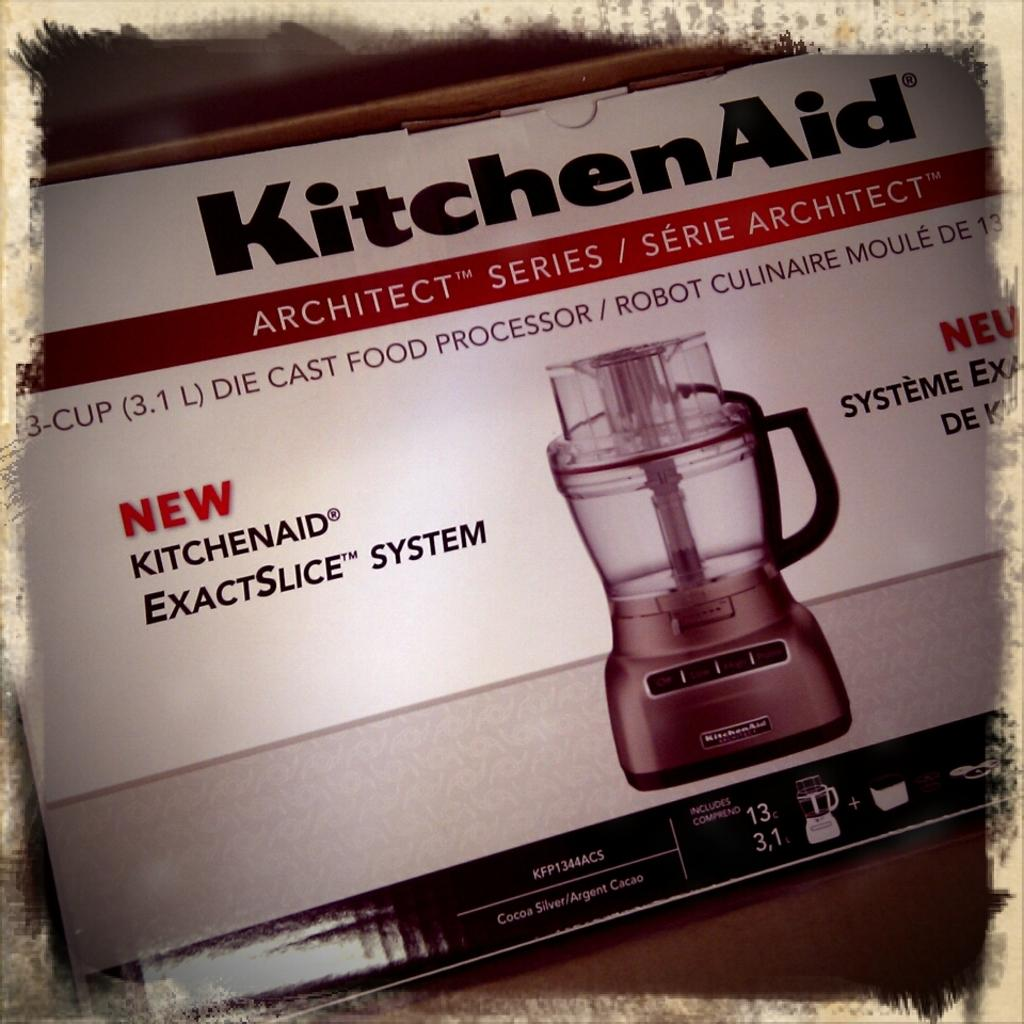What type of object might the image be depicting? The image might be a photo frame. What is shown in the picture within the frame? There is a picture of a book in the image. What is depicted in the book? The book contains an image of an electronic machine. What can be seen on the electronic machine in the book? There is text written on the electronic machine in the book. What is the smell of the cup in the image? There is no cup present in the image, so it is not possible to determine its smell. 